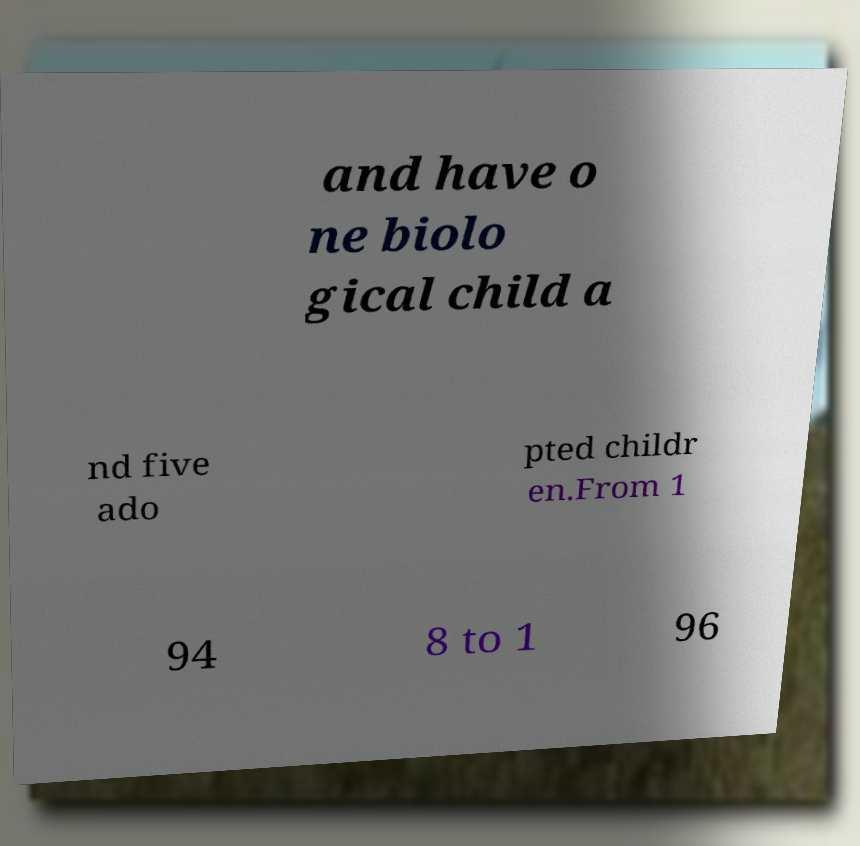I need the written content from this picture converted into text. Can you do that? and have o ne biolo gical child a nd five ado pted childr en.From 1 94 8 to 1 96 